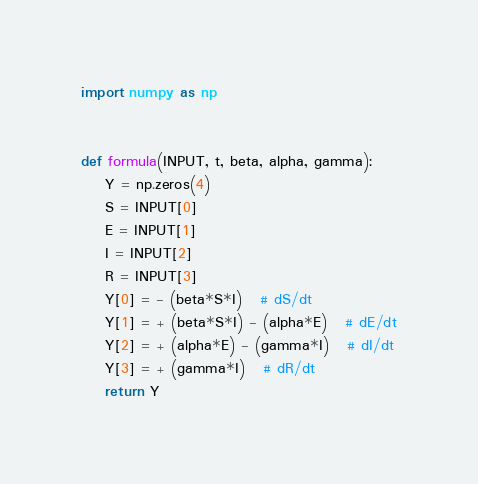<code> <loc_0><loc_0><loc_500><loc_500><_Python_>import numpy as np


def formula(INPUT, t, beta, alpha, gamma):
    Y = np.zeros(4)
    S = INPUT[0]
    E = INPUT[1]
    I = INPUT[2]
    R = INPUT[3]
    Y[0] = - (beta*S*I)   # dS/dt
    Y[1] = + (beta*S*I) - (alpha*E)   # dE/dt
    Y[2] = + (alpha*E) - (gamma*I)   # dI/dt
    Y[3] = + (gamma*I)   # dR/dt
    return Y
</code> 